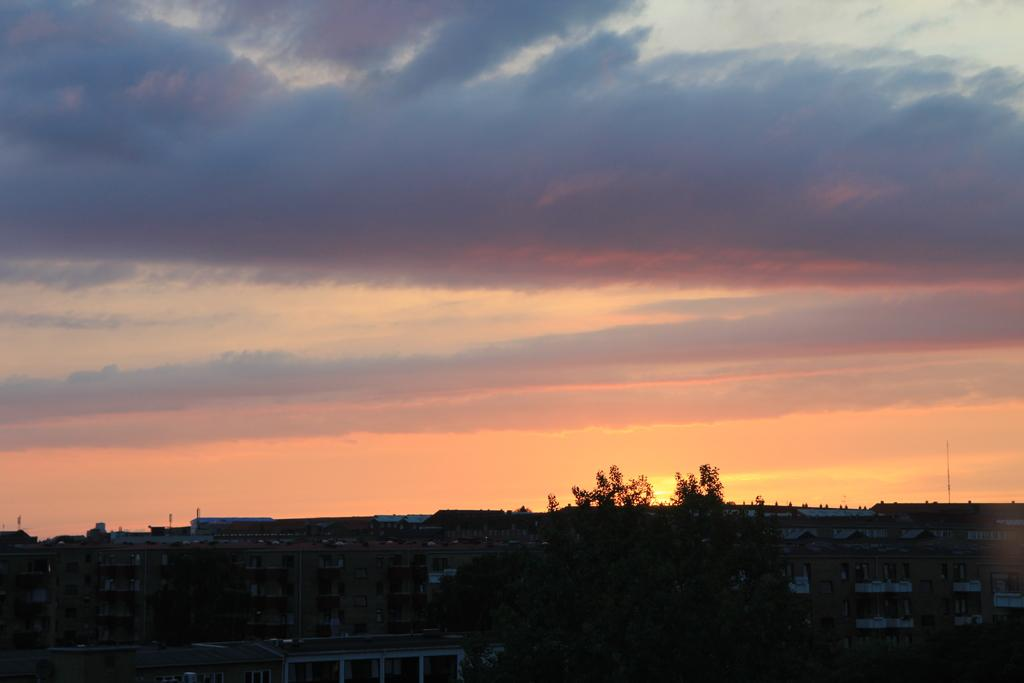What type of structures can be seen in the image? There are buildings in the image. What is located at the bottom of the image? There is a tree at the bottom of the image. What is visible at the top of the image? The sky is visible at the top of the image. What type of bun is hanging from the bell in the image? There is no bell or bun present in the image. 